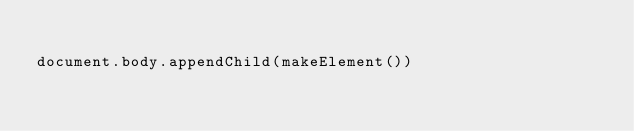Convert code to text. <code><loc_0><loc_0><loc_500><loc_500><_JavaScript_>
document.body.appendChild(makeElement())
</code> 